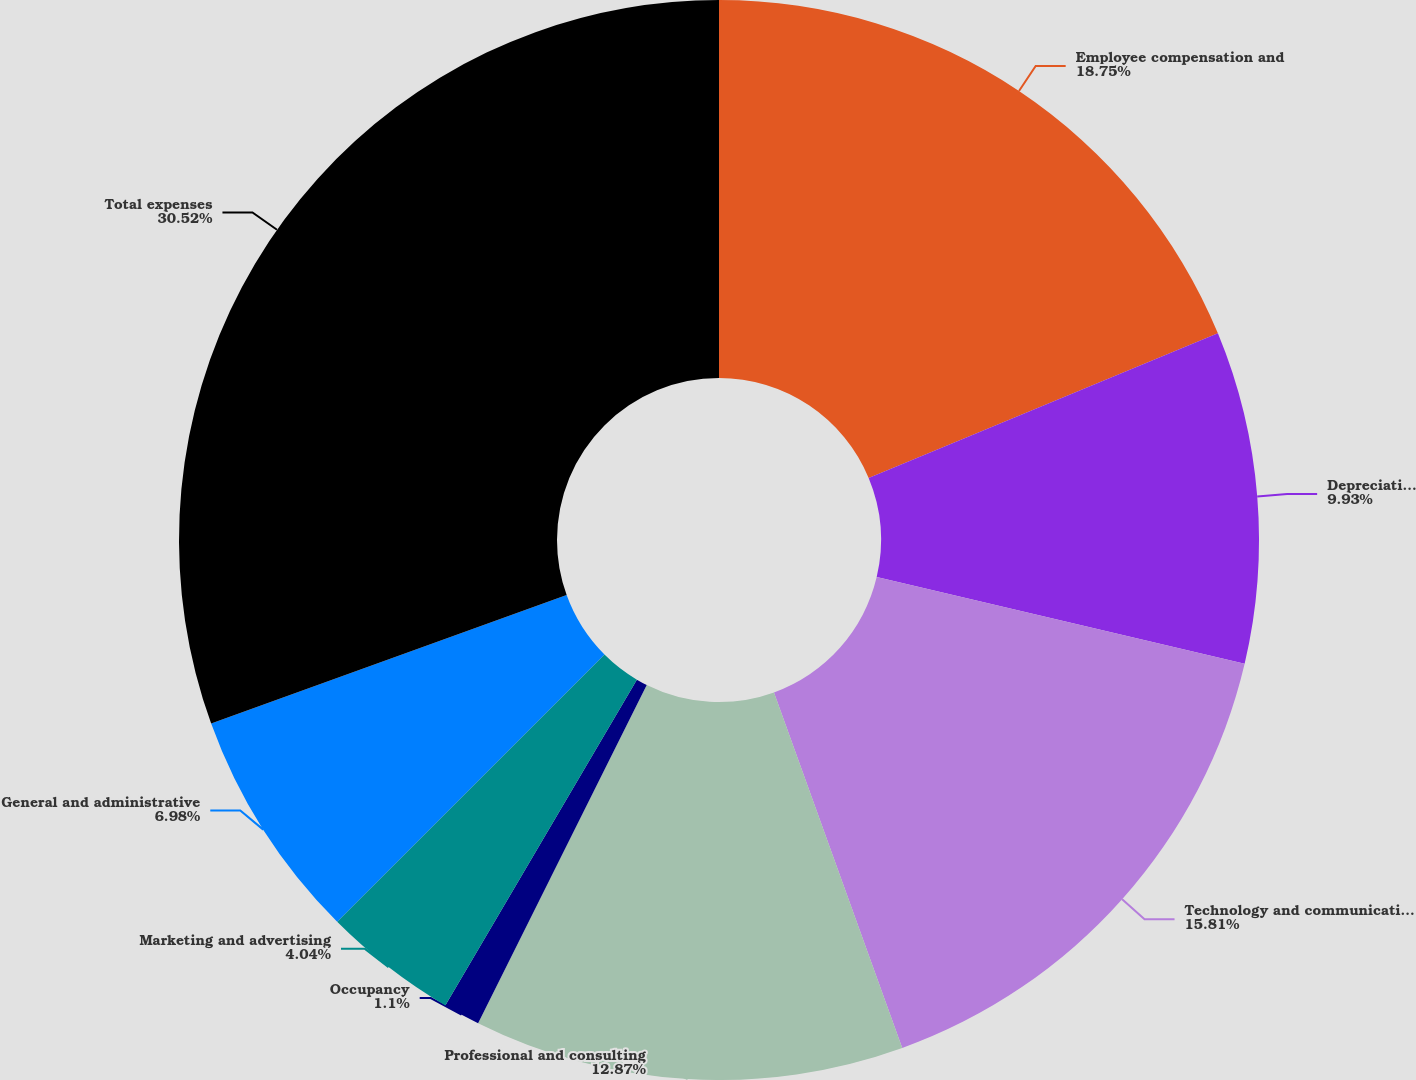<chart> <loc_0><loc_0><loc_500><loc_500><pie_chart><fcel>Employee compensation and<fcel>Depreciation and amortization<fcel>Technology and communications<fcel>Professional and consulting<fcel>Occupancy<fcel>Marketing and advertising<fcel>General and administrative<fcel>Total expenses<nl><fcel>18.75%<fcel>9.93%<fcel>15.81%<fcel>12.87%<fcel>1.1%<fcel>4.04%<fcel>6.98%<fcel>30.52%<nl></chart> 